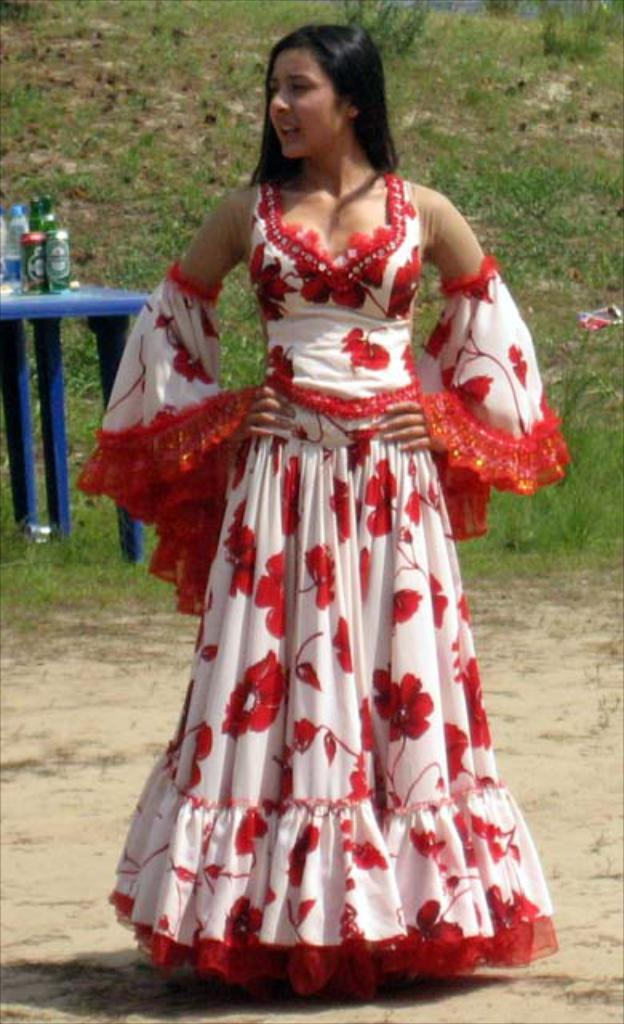Who is the main subject in the image? There is a woman in the image. What is the woman wearing? The woman is wearing a beautiful dress. What can be seen in the background of the image? There is grass and a table in the background of the image. What objects are on the table? There is a bottle and a tin on the table. How many family members are present in the image? The image only shows a woman, so it cannot be determined how many family members are present. Can you tell me what type of cat is sitting on the table? There is no cat present in the image; only a bottle and a tin are on the table. 